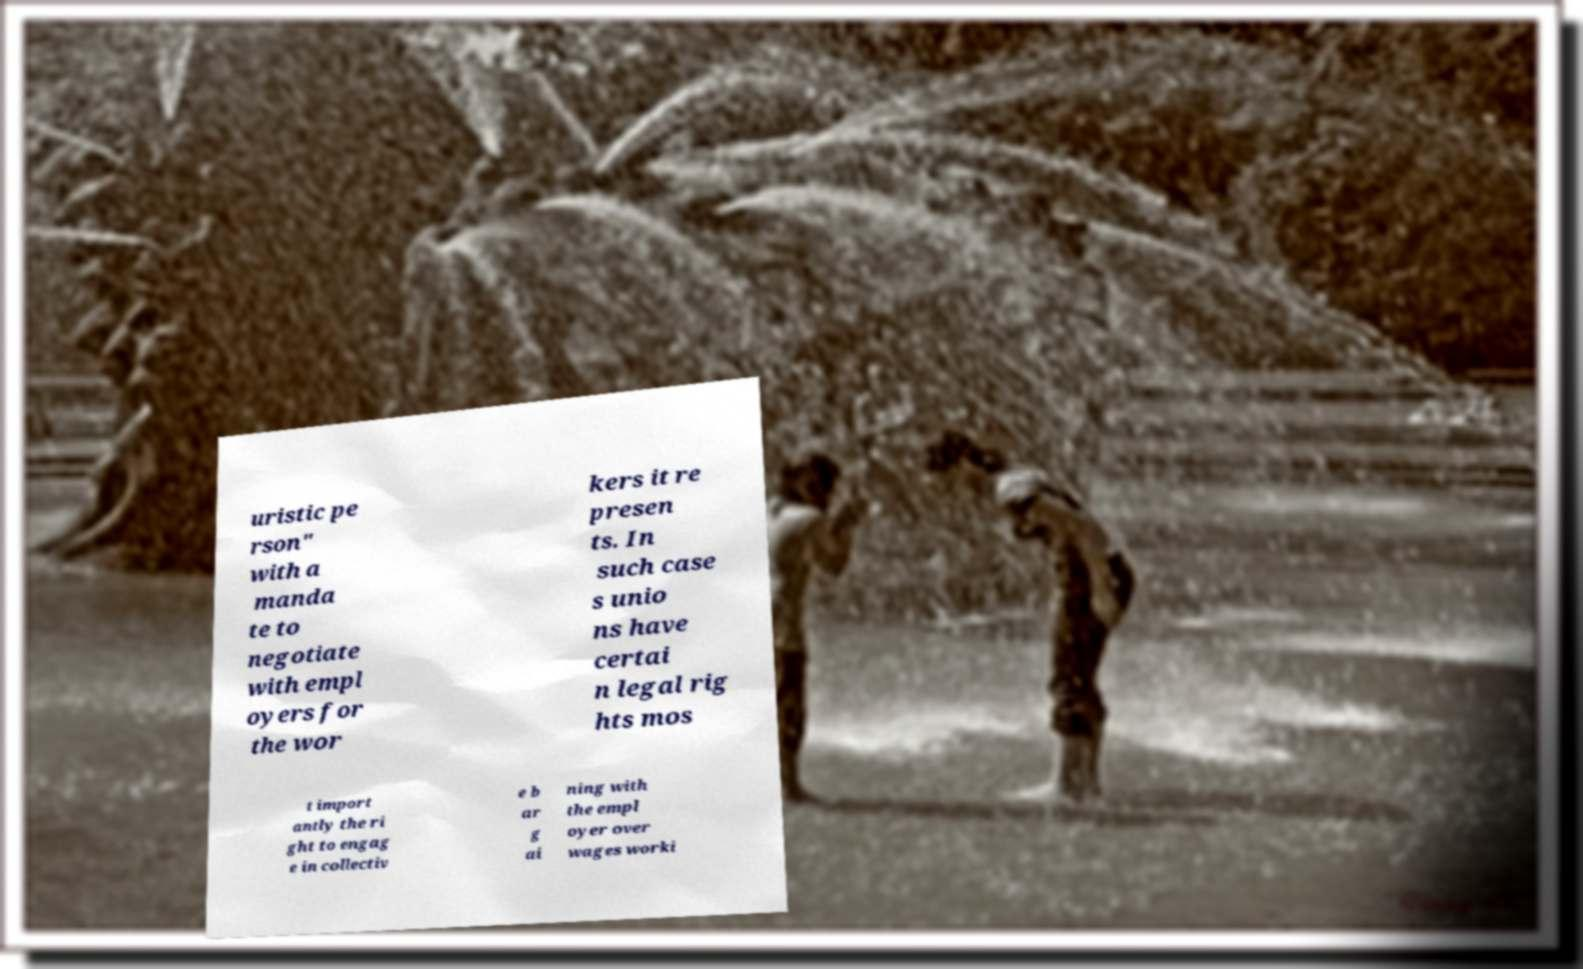Please read and relay the text visible in this image. What does it say? uristic pe rson" with a manda te to negotiate with empl oyers for the wor kers it re presen ts. In such case s unio ns have certai n legal rig hts mos t import antly the ri ght to engag e in collectiv e b ar g ai ning with the empl oyer over wages worki 